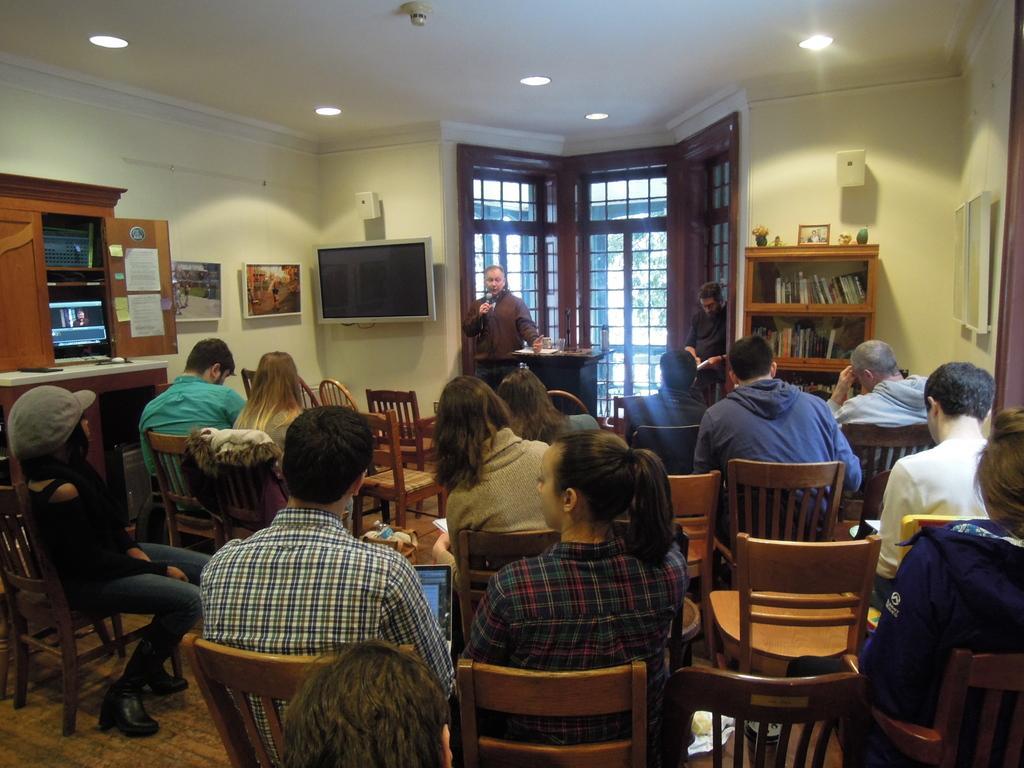Please provide a concise description of this image. There are many people sitting on chairs. And a person is standing and holding a mic and talking. And there is a wall, window, cupboards with book, photo frames. Inside the cupboard there is a TV. On the wall there is a TV. On the ceiling there are lights. 